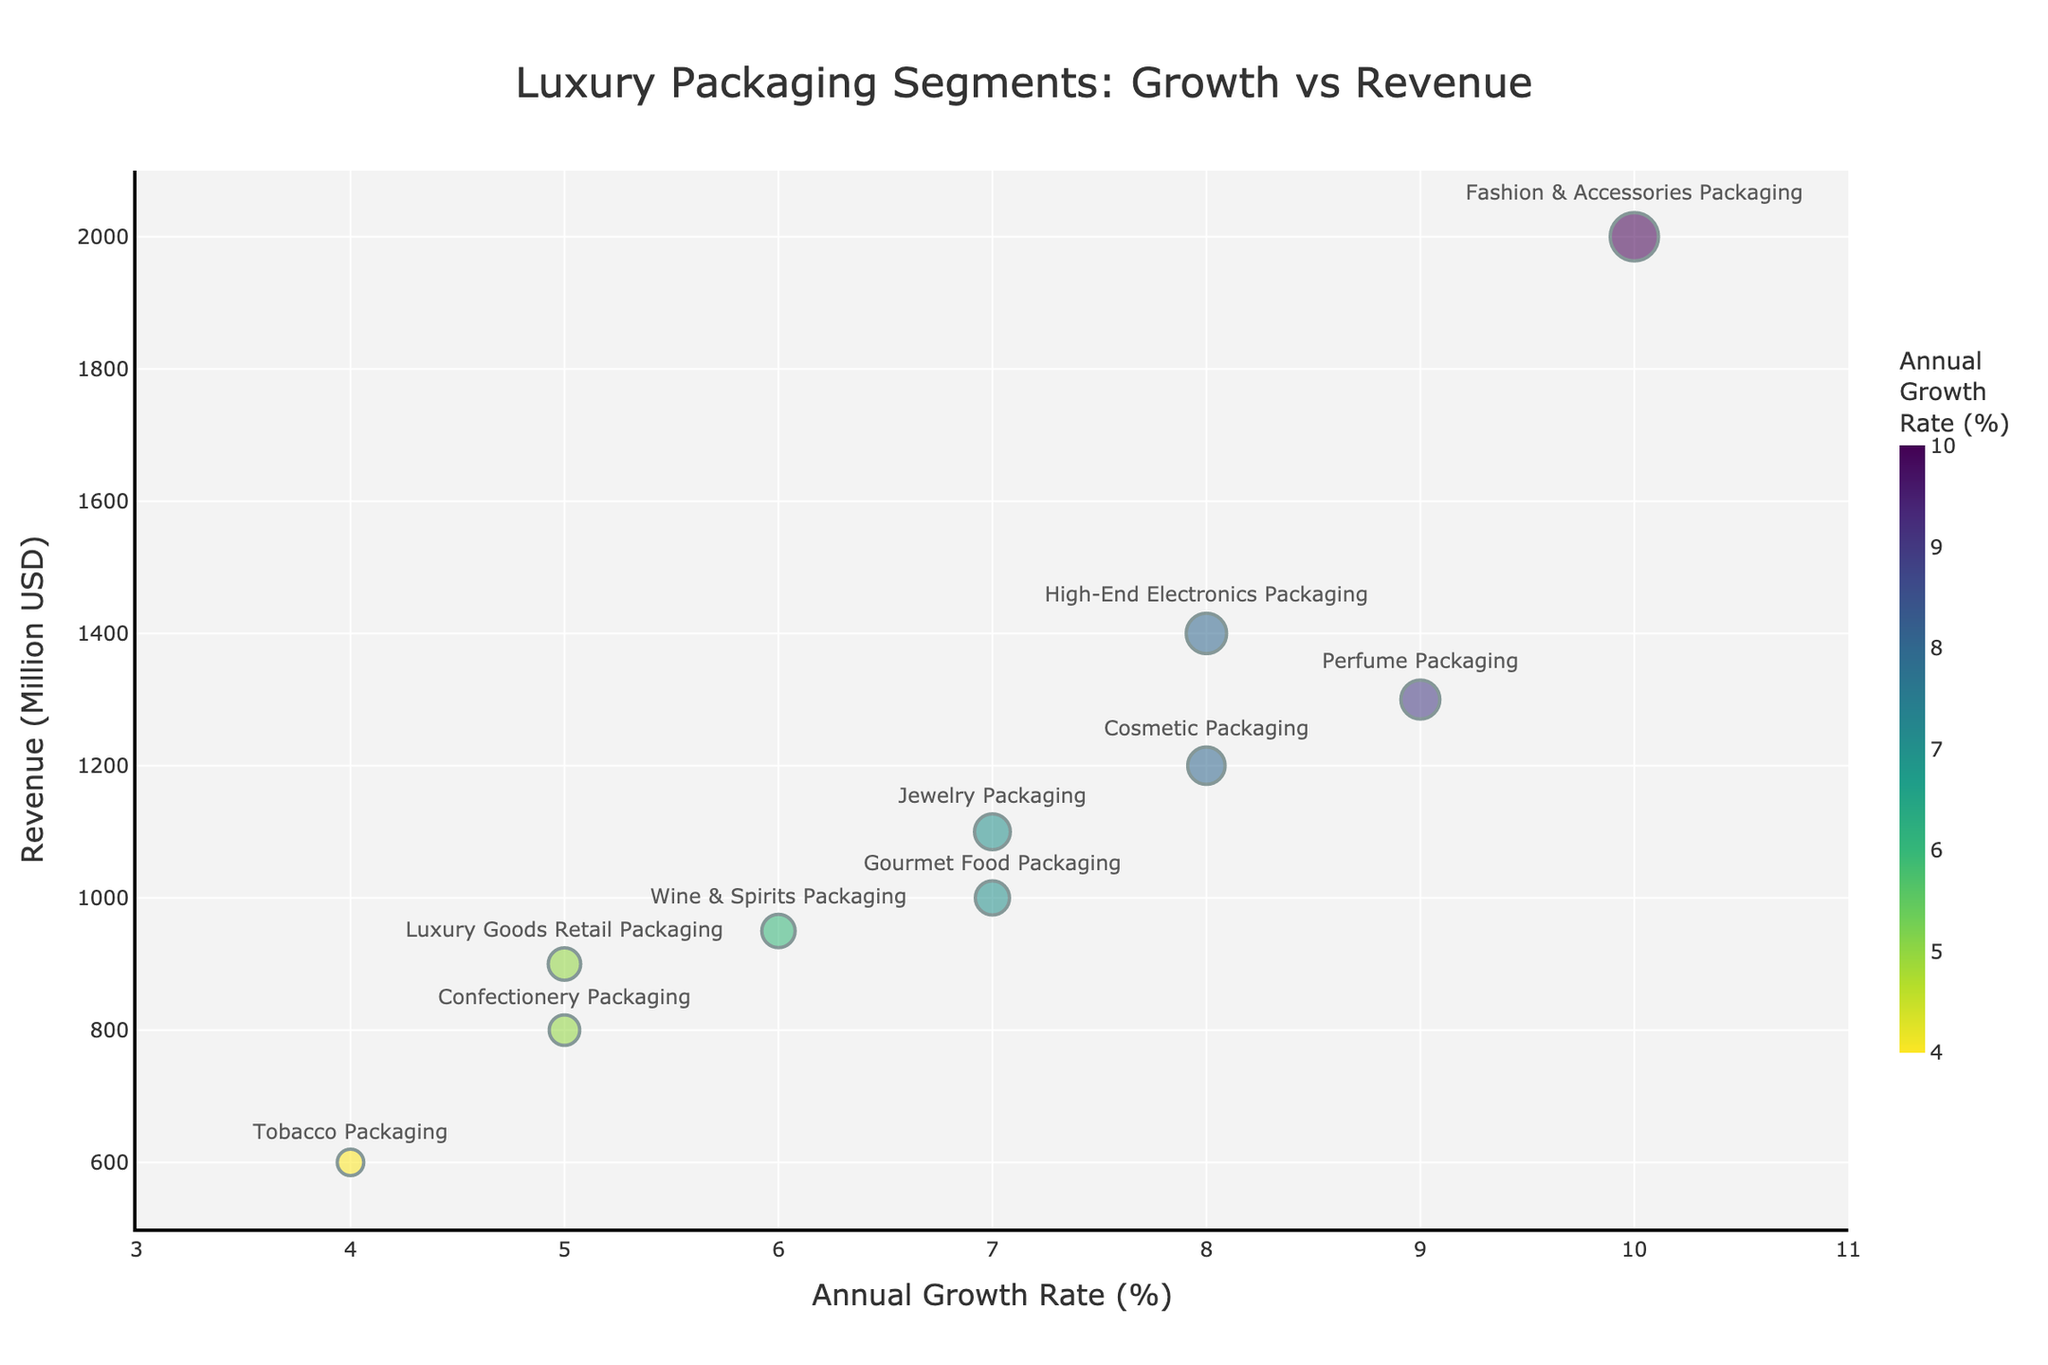What's the title of the chart? The title is displayed at the top center of the chart. It reads: "Luxury Packaging Segments: Growth vs Revenue"
Answer: Luxury Packaging Segments: Growth vs Revenue How many segments are compared in the bubble chart? Count the number of unique bubbles on the chart. Each bubble represents one segment.
Answer: 10 Which segment has the highest annual growth rate? Look for the bubble positioned farthest to the right on the x-axis labeled "Annual Growth Rate (%)".
Answer: Fashion & Accessories Packaging What is the annual growth rate and revenue for the segment with the smallest bubble? Identify the smallest bubble by size, then check its position on the x-axis for growth rate and y-axis for revenue.
Answer: Tobacco Packaging, 4%, 600 Million USD Which segment generates the highest revenue? Look for the bubble positioned highest on the y-axis labeled "Revenue (Million USD)".
Answer: Fashion & Accessories Packaging Compare the annual growth rates of Confectionery Packaging and Gourmet Food Packaging. Which is higher? Locate the bubbles for both Confectionery Packaging and Gourmet Food Packaging, then compare their x-axis positions.
Answer: Gourmet Food Packaging What is the combined revenue of Cosmetic Packaging and Perfume Packaging? Find the y-axis positions for both segments, then sum their values: 1200 Million USD (Cosmetic Packaging) + 1300 Million USD (Perfume Packaging) = 2500 Million USD
Answer: 2500 Million USD Which two segments have the closest annual growth rates? Compare the x-axis positions to find the two segments that are nearest to each other.
Answer: Cosmetic Packaging and High-End Electronics Packaging Which segment has a higher revenue, Luxury Goods Retail Packaging or Wine & Spirits Packaging? Compare the y-axis positions of the two segments.
Answer: Wine & Spirits Packaging What's the difference in revenue between Jewelry Packaging and Confectionery Packaging? Subtract the y-axis value of Confectionery Packaging from Jewelry Packaging: 1100 Million USD - 800 Million USD = 300 Million USD
Answer: 300 Million USD 